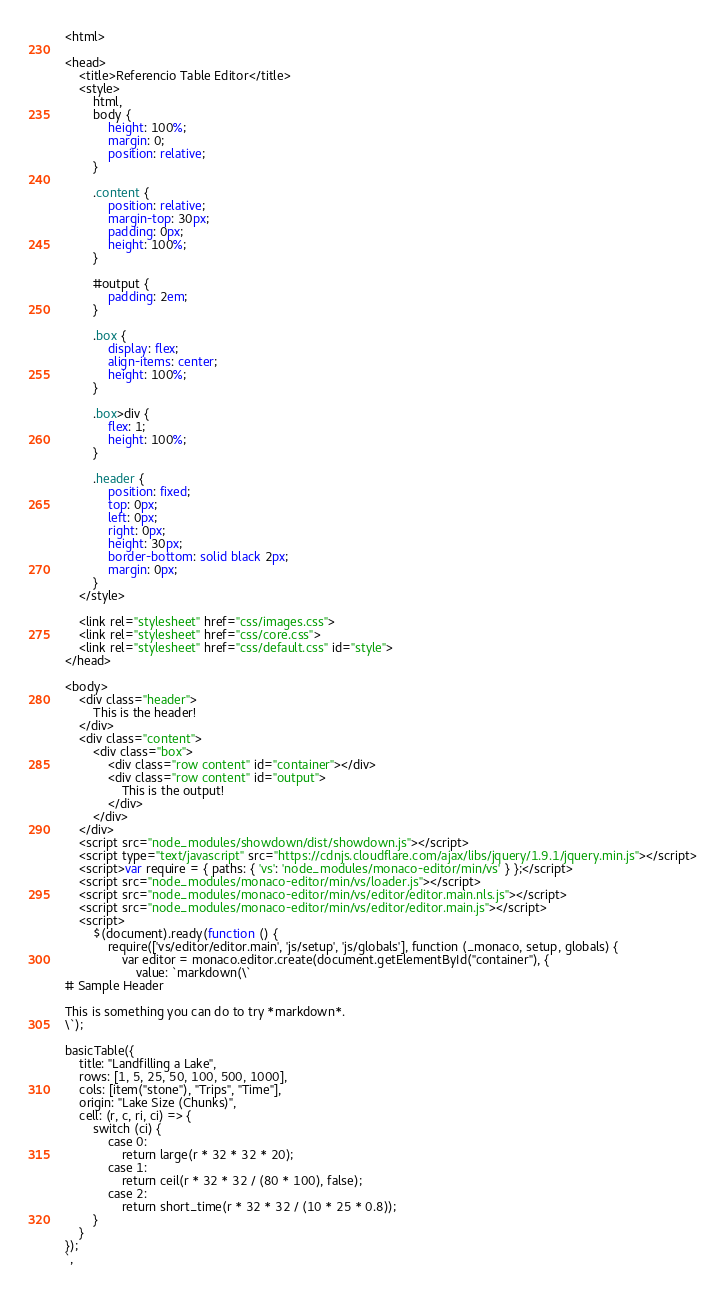<code> <loc_0><loc_0><loc_500><loc_500><_HTML_><html>

<head>
	<title>Referencio Table Editor</title>
	<style>
		html,
		body {
			height: 100%;
			margin: 0;
			position: relative;
		}

		.content {
			position: relative;
			margin-top: 30px;
			padding: 0px;
			height: 100%;
		}

		#output {
			padding: 2em;
		}

		.box {
			display: flex;
			align-items: center;
			height: 100%;
		}

		.box>div {
			flex: 1;
			height: 100%;
		}

		.header {
			position: fixed;
			top: 0px;
			left: 0px;
			right: 0px;
			height: 30px;
			border-bottom: solid black 2px;
			margin: 0px;
		}
	</style>

	<link rel="stylesheet" href="css/images.css">
	<link rel="stylesheet" href="css/core.css">
	<link rel="stylesheet" href="css/default.css" id="style">
</head>

<body>
	<div class="header">
		This is the header!
	</div>
	<div class="content">
		<div class="box">
			<div class="row content" id="container"></div>
			<div class="row content" id="output">
				This is the output!
			</div>
		</div>
	</div>
	<script src="node_modules/showdown/dist/showdown.js"></script>
	<script type="text/javascript" src="https://cdnjs.cloudflare.com/ajax/libs/jquery/1.9.1/jquery.min.js"></script>
	<script>var require = { paths: { 'vs': 'node_modules/monaco-editor/min/vs' } };</script>
	<script src="node_modules/monaco-editor/min/vs/loader.js"></script>
	<script src="node_modules/monaco-editor/min/vs/editor/editor.main.nls.js"></script>
	<script src="node_modules/monaco-editor/min/vs/editor/editor.main.js"></script>
	<script>
		$(document).ready(function () {
			require(['vs/editor/editor.main', 'js/setup', 'js/globals'], function (_monaco, setup, globals) {
				var editor = monaco.editor.create(document.getElementById("container"), {
					value: `markdown(\`
# Sample Header

This is something you can do to try *markdown*.
\`);

basicTable({
	title: "Landfilling a Lake",
	rows: [1, 5, 25, 50, 100, 500, 1000],
	cols: [item("stone"), "Trips", "Time"],
	origin: "Lake Size (Chunks)",
	cell: (r, c, ri, ci) => {
		switch (ci) {
			case 0:
				return large(r * 32 * 32 * 20);
			case 1:
				return ceil(r * 32 * 32 / (80 * 100), false);
			case 2:
				return short_time(r * 32 * 32 / (10 * 25 * 0.8));
		}
	}
});
`,</code> 